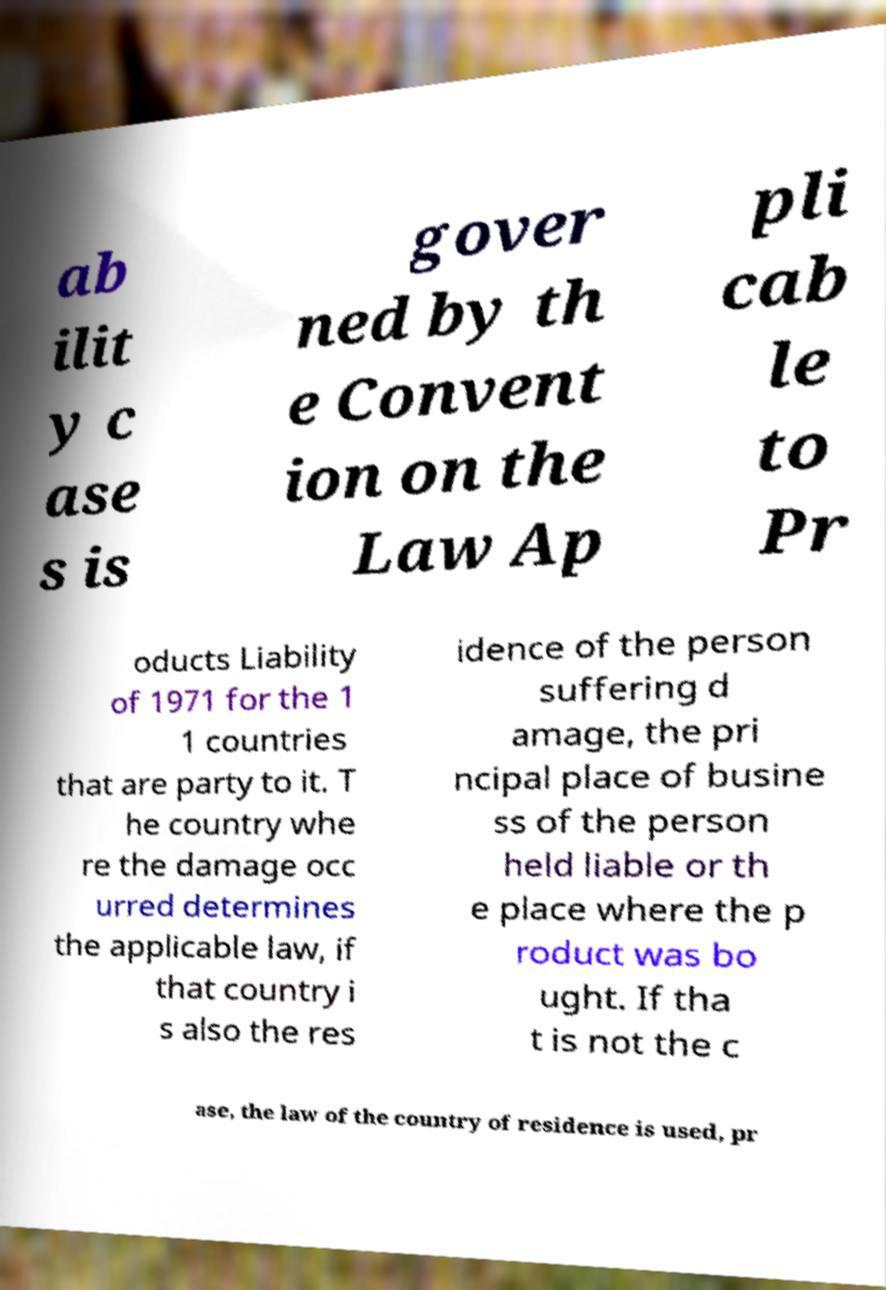I need the written content from this picture converted into text. Can you do that? ab ilit y c ase s is gover ned by th e Convent ion on the Law Ap pli cab le to Pr oducts Liability of 1971 for the 1 1 countries that are party to it. T he country whe re the damage occ urred determines the applicable law, if that country i s also the res idence of the person suffering d amage, the pri ncipal place of busine ss of the person held liable or th e place where the p roduct was bo ught. If tha t is not the c ase, the law of the country of residence is used, pr 